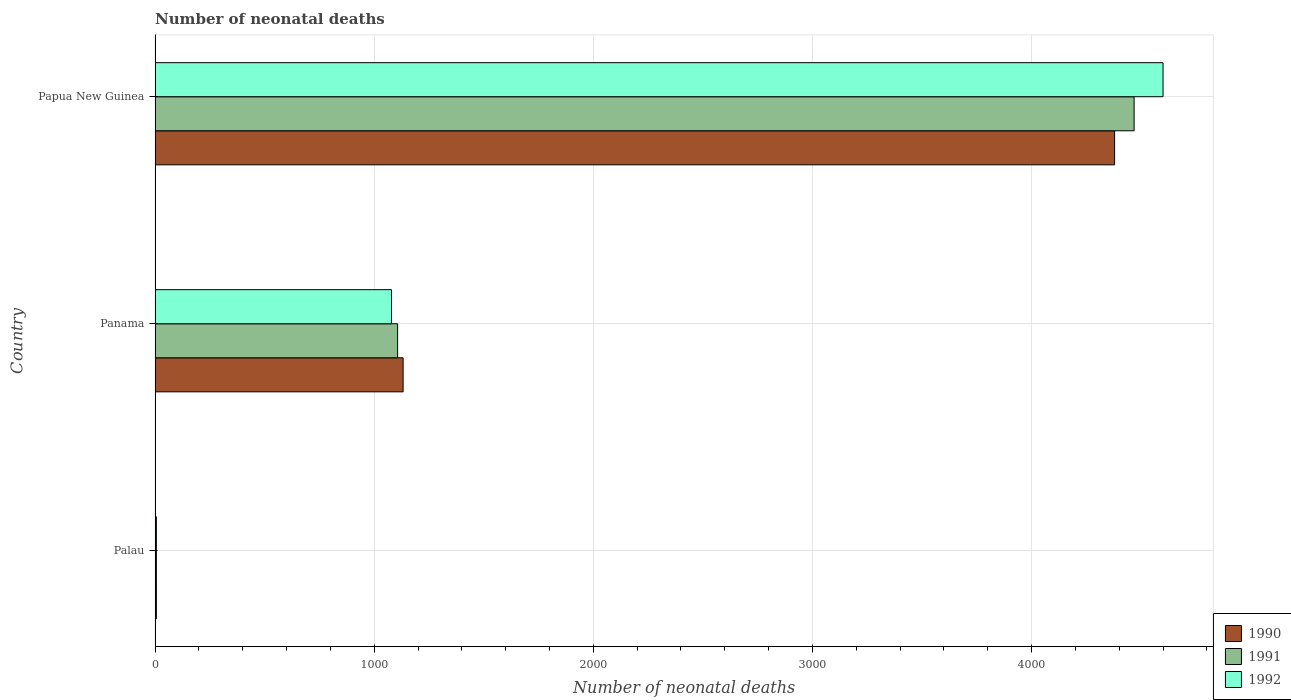How many different coloured bars are there?
Give a very brief answer. 3. Are the number of bars on each tick of the Y-axis equal?
Offer a very short reply. Yes. How many bars are there on the 3rd tick from the bottom?
Provide a succinct answer. 3. What is the label of the 3rd group of bars from the top?
Your answer should be very brief. Palau. What is the number of neonatal deaths in in 1990 in Papua New Guinea?
Your response must be concise. 4379. Across all countries, what is the maximum number of neonatal deaths in in 1992?
Provide a succinct answer. 4600. In which country was the number of neonatal deaths in in 1992 maximum?
Keep it short and to the point. Papua New Guinea. In which country was the number of neonatal deaths in in 1991 minimum?
Make the answer very short. Palau. What is the total number of neonatal deaths in in 1992 in the graph?
Ensure brevity in your answer.  5685. What is the difference between the number of neonatal deaths in in 1992 in Palau and that in Papua New Guinea?
Make the answer very short. -4594. What is the difference between the number of neonatal deaths in in 1991 in Panama and the number of neonatal deaths in in 1990 in Papua New Guinea?
Provide a short and direct response. -3272. What is the average number of neonatal deaths in in 1992 per country?
Keep it short and to the point. 1895. What is the difference between the number of neonatal deaths in in 1990 and number of neonatal deaths in in 1991 in Panama?
Offer a very short reply. 25. What is the ratio of the number of neonatal deaths in in 1991 in Palau to that in Papua New Guinea?
Your answer should be very brief. 0. Is the difference between the number of neonatal deaths in in 1990 in Palau and Papua New Guinea greater than the difference between the number of neonatal deaths in in 1991 in Palau and Papua New Guinea?
Provide a short and direct response. Yes. What is the difference between the highest and the second highest number of neonatal deaths in in 1990?
Keep it short and to the point. 3247. What is the difference between the highest and the lowest number of neonatal deaths in in 1992?
Provide a succinct answer. 4594. What does the 2nd bar from the top in Panama represents?
Provide a short and direct response. 1991. What does the 2nd bar from the bottom in Papua New Guinea represents?
Ensure brevity in your answer.  1991. How many bars are there?
Offer a terse response. 9. How many countries are there in the graph?
Provide a short and direct response. 3. Are the values on the major ticks of X-axis written in scientific E-notation?
Offer a very short reply. No. Does the graph contain any zero values?
Offer a very short reply. No. Does the graph contain grids?
Offer a terse response. Yes. Where does the legend appear in the graph?
Make the answer very short. Bottom right. How many legend labels are there?
Offer a very short reply. 3. What is the title of the graph?
Offer a terse response. Number of neonatal deaths. What is the label or title of the X-axis?
Provide a short and direct response. Number of neonatal deaths. What is the Number of neonatal deaths of 1990 in Palau?
Your answer should be very brief. 6. What is the Number of neonatal deaths of 1992 in Palau?
Make the answer very short. 6. What is the Number of neonatal deaths in 1990 in Panama?
Your answer should be compact. 1132. What is the Number of neonatal deaths in 1991 in Panama?
Give a very brief answer. 1107. What is the Number of neonatal deaths of 1992 in Panama?
Provide a short and direct response. 1079. What is the Number of neonatal deaths of 1990 in Papua New Guinea?
Ensure brevity in your answer.  4379. What is the Number of neonatal deaths of 1991 in Papua New Guinea?
Your response must be concise. 4468. What is the Number of neonatal deaths in 1992 in Papua New Guinea?
Provide a succinct answer. 4600. Across all countries, what is the maximum Number of neonatal deaths in 1990?
Your answer should be very brief. 4379. Across all countries, what is the maximum Number of neonatal deaths in 1991?
Give a very brief answer. 4468. Across all countries, what is the maximum Number of neonatal deaths in 1992?
Ensure brevity in your answer.  4600. Across all countries, what is the minimum Number of neonatal deaths in 1990?
Provide a short and direct response. 6. Across all countries, what is the minimum Number of neonatal deaths in 1991?
Give a very brief answer. 6. Across all countries, what is the minimum Number of neonatal deaths in 1992?
Provide a succinct answer. 6. What is the total Number of neonatal deaths of 1990 in the graph?
Your answer should be compact. 5517. What is the total Number of neonatal deaths of 1991 in the graph?
Your response must be concise. 5581. What is the total Number of neonatal deaths in 1992 in the graph?
Offer a terse response. 5685. What is the difference between the Number of neonatal deaths in 1990 in Palau and that in Panama?
Provide a succinct answer. -1126. What is the difference between the Number of neonatal deaths of 1991 in Palau and that in Panama?
Make the answer very short. -1101. What is the difference between the Number of neonatal deaths of 1992 in Palau and that in Panama?
Give a very brief answer. -1073. What is the difference between the Number of neonatal deaths in 1990 in Palau and that in Papua New Guinea?
Your answer should be very brief. -4373. What is the difference between the Number of neonatal deaths in 1991 in Palau and that in Papua New Guinea?
Provide a short and direct response. -4462. What is the difference between the Number of neonatal deaths in 1992 in Palau and that in Papua New Guinea?
Your answer should be compact. -4594. What is the difference between the Number of neonatal deaths of 1990 in Panama and that in Papua New Guinea?
Make the answer very short. -3247. What is the difference between the Number of neonatal deaths in 1991 in Panama and that in Papua New Guinea?
Your response must be concise. -3361. What is the difference between the Number of neonatal deaths in 1992 in Panama and that in Papua New Guinea?
Give a very brief answer. -3521. What is the difference between the Number of neonatal deaths in 1990 in Palau and the Number of neonatal deaths in 1991 in Panama?
Your answer should be very brief. -1101. What is the difference between the Number of neonatal deaths in 1990 in Palau and the Number of neonatal deaths in 1992 in Panama?
Offer a very short reply. -1073. What is the difference between the Number of neonatal deaths in 1991 in Palau and the Number of neonatal deaths in 1992 in Panama?
Give a very brief answer. -1073. What is the difference between the Number of neonatal deaths of 1990 in Palau and the Number of neonatal deaths of 1991 in Papua New Guinea?
Keep it short and to the point. -4462. What is the difference between the Number of neonatal deaths in 1990 in Palau and the Number of neonatal deaths in 1992 in Papua New Guinea?
Give a very brief answer. -4594. What is the difference between the Number of neonatal deaths of 1991 in Palau and the Number of neonatal deaths of 1992 in Papua New Guinea?
Your answer should be compact. -4594. What is the difference between the Number of neonatal deaths of 1990 in Panama and the Number of neonatal deaths of 1991 in Papua New Guinea?
Keep it short and to the point. -3336. What is the difference between the Number of neonatal deaths of 1990 in Panama and the Number of neonatal deaths of 1992 in Papua New Guinea?
Offer a terse response. -3468. What is the difference between the Number of neonatal deaths of 1991 in Panama and the Number of neonatal deaths of 1992 in Papua New Guinea?
Offer a terse response. -3493. What is the average Number of neonatal deaths in 1990 per country?
Your answer should be very brief. 1839. What is the average Number of neonatal deaths of 1991 per country?
Provide a short and direct response. 1860.33. What is the average Number of neonatal deaths of 1992 per country?
Provide a succinct answer. 1895. What is the difference between the Number of neonatal deaths of 1991 and Number of neonatal deaths of 1992 in Palau?
Provide a succinct answer. 0. What is the difference between the Number of neonatal deaths in 1990 and Number of neonatal deaths in 1991 in Panama?
Offer a terse response. 25. What is the difference between the Number of neonatal deaths in 1991 and Number of neonatal deaths in 1992 in Panama?
Make the answer very short. 28. What is the difference between the Number of neonatal deaths of 1990 and Number of neonatal deaths of 1991 in Papua New Guinea?
Your response must be concise. -89. What is the difference between the Number of neonatal deaths in 1990 and Number of neonatal deaths in 1992 in Papua New Guinea?
Offer a terse response. -221. What is the difference between the Number of neonatal deaths in 1991 and Number of neonatal deaths in 1992 in Papua New Guinea?
Give a very brief answer. -132. What is the ratio of the Number of neonatal deaths in 1990 in Palau to that in Panama?
Ensure brevity in your answer.  0.01. What is the ratio of the Number of neonatal deaths of 1991 in Palau to that in Panama?
Make the answer very short. 0.01. What is the ratio of the Number of neonatal deaths in 1992 in Palau to that in Panama?
Your answer should be very brief. 0.01. What is the ratio of the Number of neonatal deaths of 1990 in Palau to that in Papua New Guinea?
Your response must be concise. 0. What is the ratio of the Number of neonatal deaths in 1991 in Palau to that in Papua New Guinea?
Provide a succinct answer. 0. What is the ratio of the Number of neonatal deaths in 1992 in Palau to that in Papua New Guinea?
Offer a very short reply. 0. What is the ratio of the Number of neonatal deaths in 1990 in Panama to that in Papua New Guinea?
Provide a short and direct response. 0.26. What is the ratio of the Number of neonatal deaths in 1991 in Panama to that in Papua New Guinea?
Your answer should be very brief. 0.25. What is the ratio of the Number of neonatal deaths in 1992 in Panama to that in Papua New Guinea?
Provide a succinct answer. 0.23. What is the difference between the highest and the second highest Number of neonatal deaths in 1990?
Keep it short and to the point. 3247. What is the difference between the highest and the second highest Number of neonatal deaths of 1991?
Give a very brief answer. 3361. What is the difference between the highest and the second highest Number of neonatal deaths in 1992?
Give a very brief answer. 3521. What is the difference between the highest and the lowest Number of neonatal deaths in 1990?
Give a very brief answer. 4373. What is the difference between the highest and the lowest Number of neonatal deaths of 1991?
Offer a terse response. 4462. What is the difference between the highest and the lowest Number of neonatal deaths of 1992?
Ensure brevity in your answer.  4594. 